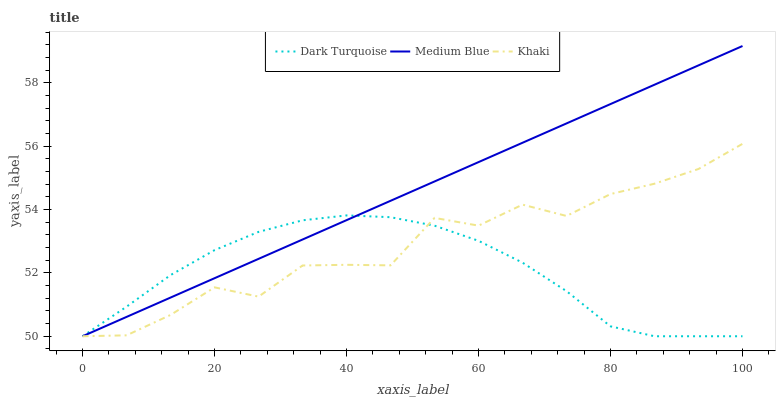Does Dark Turquoise have the minimum area under the curve?
Answer yes or no. Yes. Does Medium Blue have the maximum area under the curve?
Answer yes or no. Yes. Does Khaki have the minimum area under the curve?
Answer yes or no. No. Does Khaki have the maximum area under the curve?
Answer yes or no. No. Is Medium Blue the smoothest?
Answer yes or no. Yes. Is Khaki the roughest?
Answer yes or no. Yes. Is Khaki the smoothest?
Answer yes or no. No. Is Medium Blue the roughest?
Answer yes or no. No. Does Dark Turquoise have the lowest value?
Answer yes or no. Yes. Does Medium Blue have the highest value?
Answer yes or no. Yes. Does Khaki have the highest value?
Answer yes or no. No. Does Medium Blue intersect Khaki?
Answer yes or no. Yes. Is Medium Blue less than Khaki?
Answer yes or no. No. Is Medium Blue greater than Khaki?
Answer yes or no. No. 